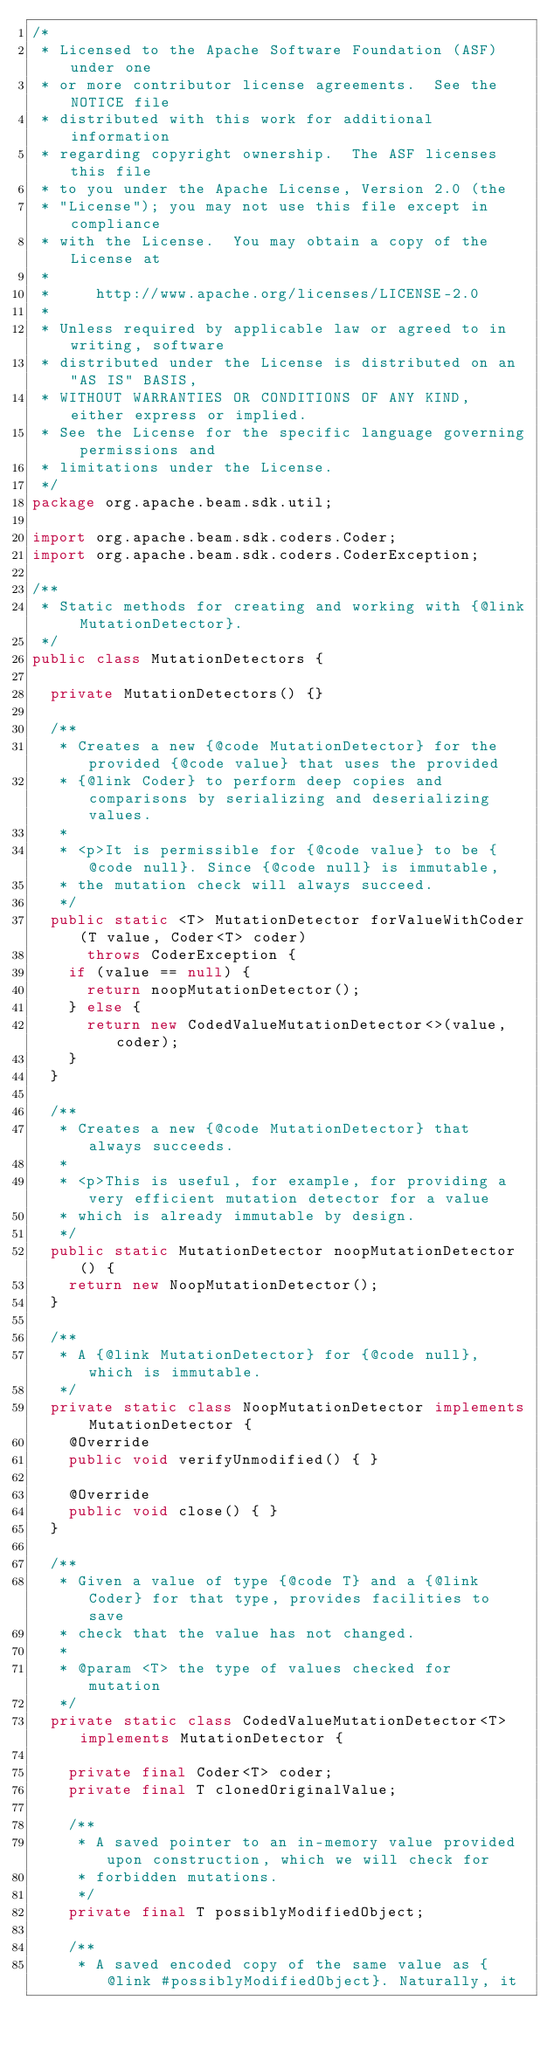<code> <loc_0><loc_0><loc_500><loc_500><_Java_>/*
 * Licensed to the Apache Software Foundation (ASF) under one
 * or more contributor license agreements.  See the NOTICE file
 * distributed with this work for additional information
 * regarding copyright ownership.  The ASF licenses this file
 * to you under the Apache License, Version 2.0 (the
 * "License"); you may not use this file except in compliance
 * with the License.  You may obtain a copy of the License at
 *
 *     http://www.apache.org/licenses/LICENSE-2.0
 *
 * Unless required by applicable law or agreed to in writing, software
 * distributed under the License is distributed on an "AS IS" BASIS,
 * WITHOUT WARRANTIES OR CONDITIONS OF ANY KIND, either express or implied.
 * See the License for the specific language governing permissions and
 * limitations under the License.
 */
package org.apache.beam.sdk.util;

import org.apache.beam.sdk.coders.Coder;
import org.apache.beam.sdk.coders.CoderException;

/**
 * Static methods for creating and working with {@link MutationDetector}.
 */
public class MutationDetectors {

  private MutationDetectors() {}

  /**
   * Creates a new {@code MutationDetector} for the provided {@code value} that uses the provided
   * {@link Coder} to perform deep copies and comparisons by serializing and deserializing values.
   *
   * <p>It is permissible for {@code value} to be {@code null}. Since {@code null} is immutable,
   * the mutation check will always succeed.
   */
  public static <T> MutationDetector forValueWithCoder(T value, Coder<T> coder)
      throws CoderException {
    if (value == null) {
      return noopMutationDetector();
    } else {
      return new CodedValueMutationDetector<>(value, coder);
    }
  }

  /**
   * Creates a new {@code MutationDetector} that always succeeds.
   *
   * <p>This is useful, for example, for providing a very efficient mutation detector for a value
   * which is already immutable by design.
   */
  public static MutationDetector noopMutationDetector() {
    return new NoopMutationDetector();
  }

  /**
   * A {@link MutationDetector} for {@code null}, which is immutable.
   */
  private static class NoopMutationDetector implements MutationDetector {
    @Override
    public void verifyUnmodified() { }

    @Override
    public void close() { }
  }

  /**
   * Given a value of type {@code T} and a {@link Coder} for that type, provides facilities to save
   * check that the value has not changed.
   *
   * @param <T> the type of values checked for mutation
   */
  private static class CodedValueMutationDetector<T> implements MutationDetector {

    private final Coder<T> coder;
    private final T clonedOriginalValue;

    /**
     * A saved pointer to an in-memory value provided upon construction, which we will check for
     * forbidden mutations.
     */
    private final T possiblyModifiedObject;

    /**
     * A saved encoded copy of the same value as {@link #possiblyModifiedObject}. Naturally, it</code> 